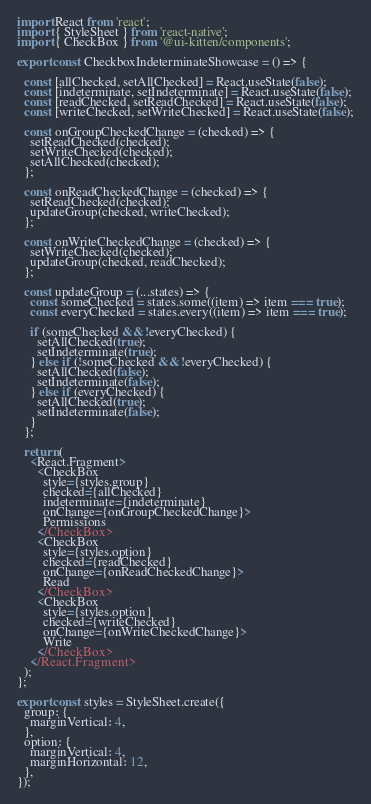Convert code to text. <code><loc_0><loc_0><loc_500><loc_500><_TypeScript_>import React from 'react';
import { StyleSheet } from 'react-native';
import { CheckBox } from '@ui-kitten/components';

export const CheckboxIndeterminateShowcase = () => {

  const [allChecked, setAllChecked] = React.useState(false);
  const [indeterminate, setIndeterminate] = React.useState(false);
  const [readChecked, setReadChecked] = React.useState(false);
  const [writeChecked, setWriteChecked] = React.useState(false);

  const onGroupCheckedChange = (checked) => {
    setReadChecked(checked);
    setWriteChecked(checked);
    setAllChecked(checked);
  };

  const onReadCheckedChange = (checked) => {
    setReadChecked(checked);
    updateGroup(checked, writeChecked);
  };

  const onWriteCheckedChange = (checked) => {
    setWriteChecked(checked);
    updateGroup(checked, readChecked);
  };

  const updateGroup = (...states) => {
    const someChecked = states.some((item) => item === true);
    const everyChecked = states.every((item) => item === true);

    if (someChecked && !everyChecked) {
      setAllChecked(true);
      setIndeterminate(true);
    } else if (!someChecked && !everyChecked) {
      setAllChecked(false);
      setIndeterminate(false);
    } else if (everyChecked) {
      setAllChecked(true);
      setIndeterminate(false);
    }
  };

  return (
    <React.Fragment>
      <CheckBox
        style={styles.group}
        checked={allChecked}
        indeterminate={indeterminate}
        onChange={onGroupCheckedChange}>
        Permissions
      </CheckBox>
      <CheckBox
        style={styles.option}
        checked={readChecked}
        onChange={onReadCheckedChange}>
        Read
      </CheckBox>
      <CheckBox
        style={styles.option}
        checked={writeChecked}
        onChange={onWriteCheckedChange}>
        Write
      </CheckBox>
    </React.Fragment>
  );
};

export const styles = StyleSheet.create({
  group: {
    marginVertical: 4,
  },
  option: {
    marginVertical: 4,
    marginHorizontal: 12,
  },
});
</code> 